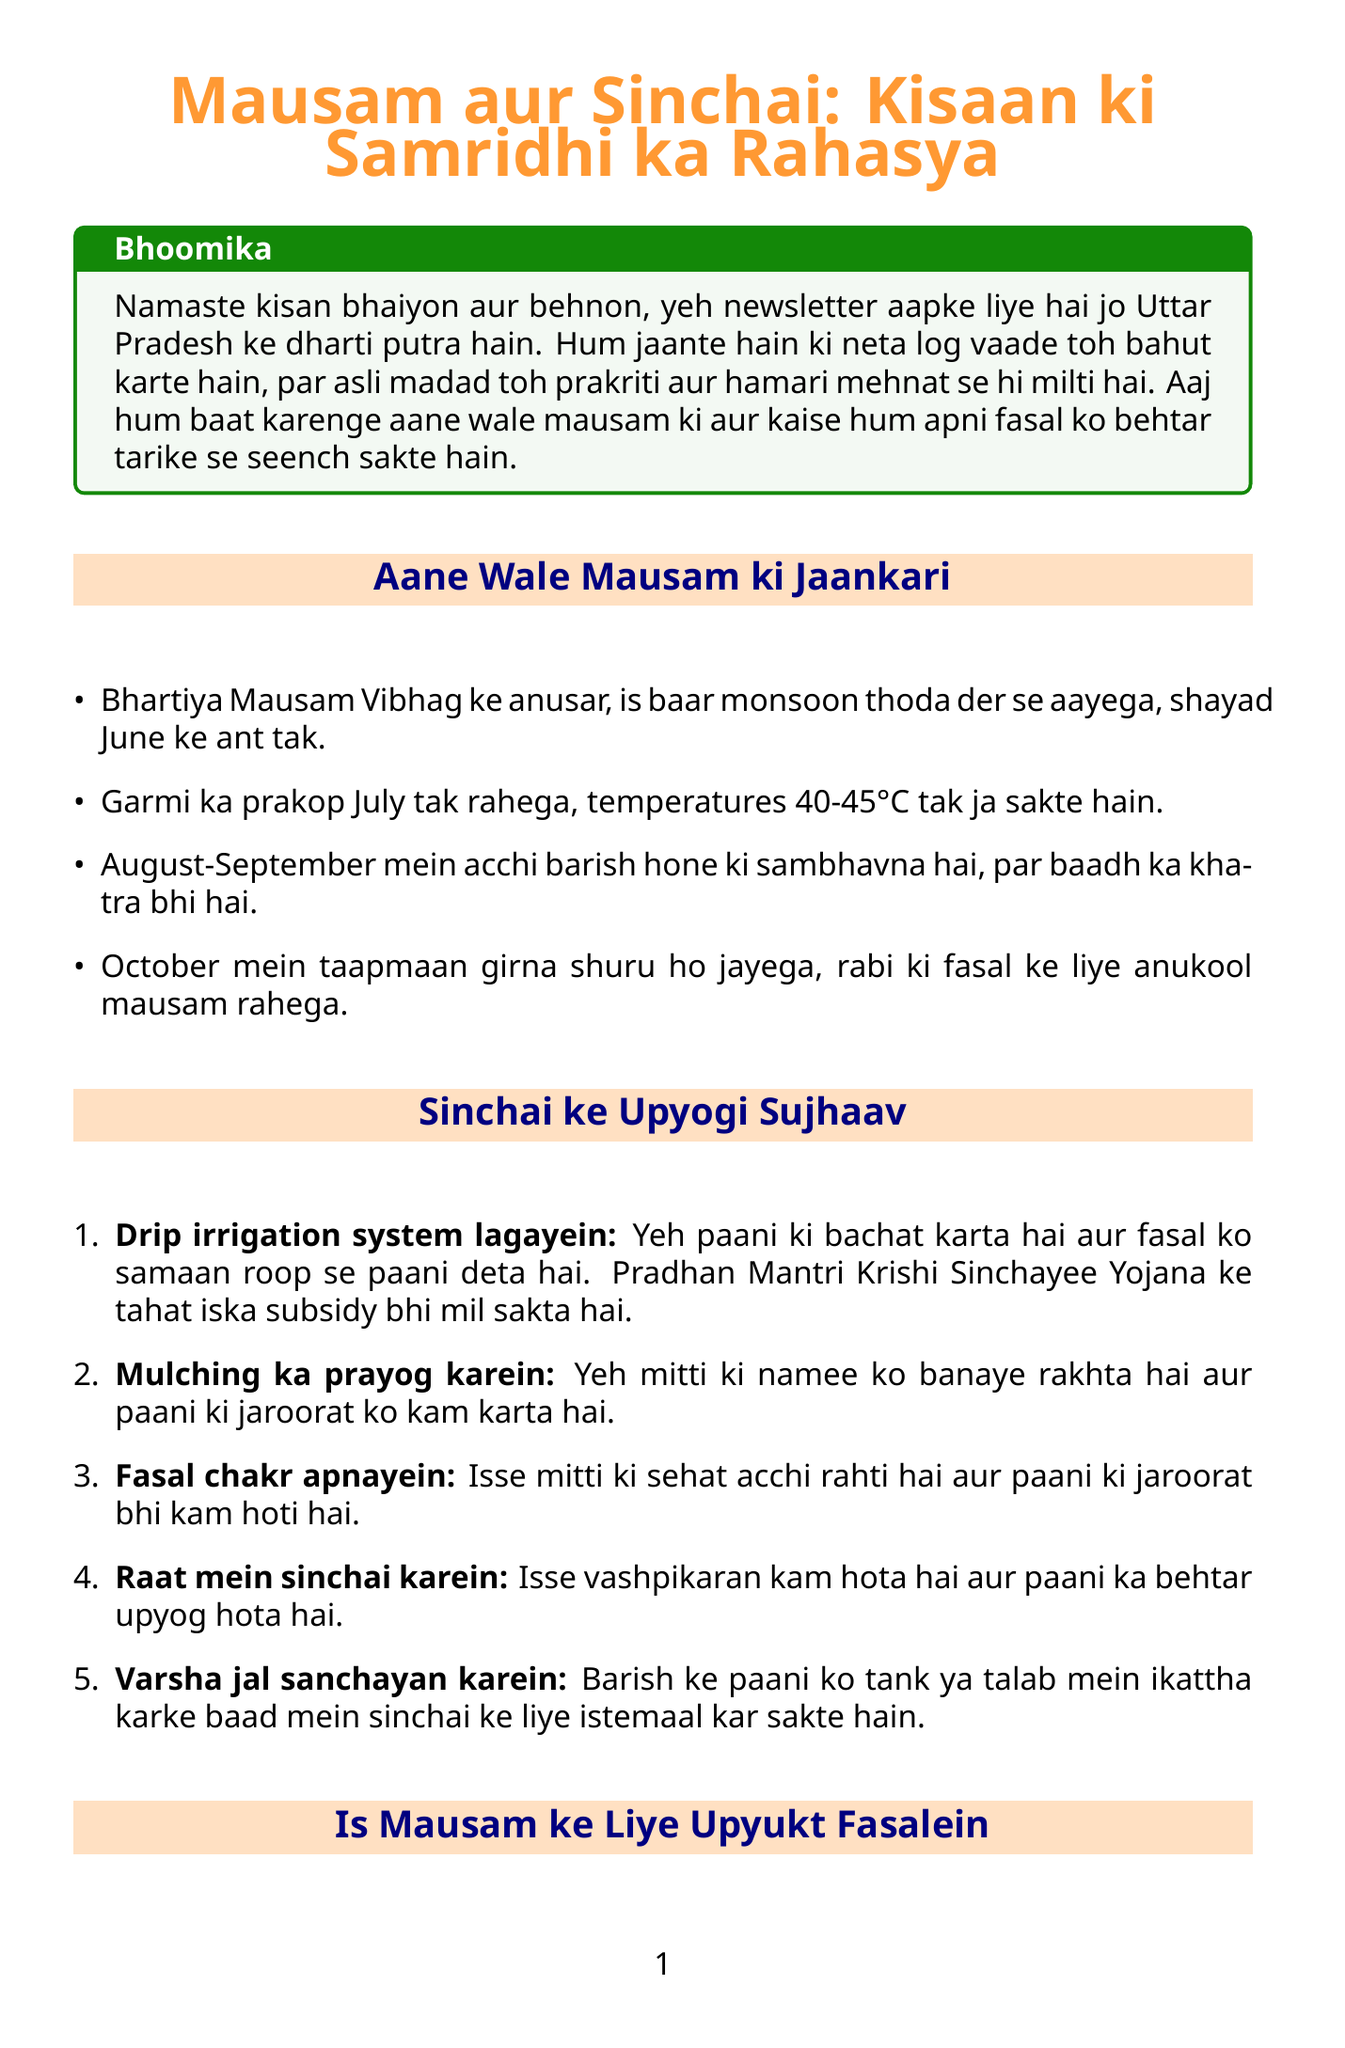What is the title of the newsletter? The title of the newsletter is mentioned at the beginning of the document.
Answer: Mausam aur Sinchai: Kisaan ki Samridhi ka Rahasya When is the expected arrival of the monsoon? The document provides information about the monsoon's expected arrival.
Answer: June ke ant tak What temperature might be reached in July? The document states the potential temperatures during July.
Answer: 40-45°C What irrigation system is recommended? The document lists beneficial irrigation systems for farmers.
Answer: Drip irrigation system What is the recommended crop for Kharif season? The document lists specific crops suitable for the Kharif season.
Answer: Dhaan (MTU 7029 ya Pusa Basmati 1509) How much financial aid is provided under PM Kisan Samman Nidhi? The document specifies the monetary assistance under this government scheme.
Answer: 6000 rupaye What is the price of Arhar in the local market? The document provides local market prices for various crops.
Answer: 6300 Which government scheme helps with soil health? The document mentions various schemes regarding support for farmers, including soil health.
Answer: Soil Health Card Scheme Why should farmers practice mulching? The document explains the benefits of mulching in irrigation tips.
Answer: Mitti ki namee ko banaye rakhta hai 